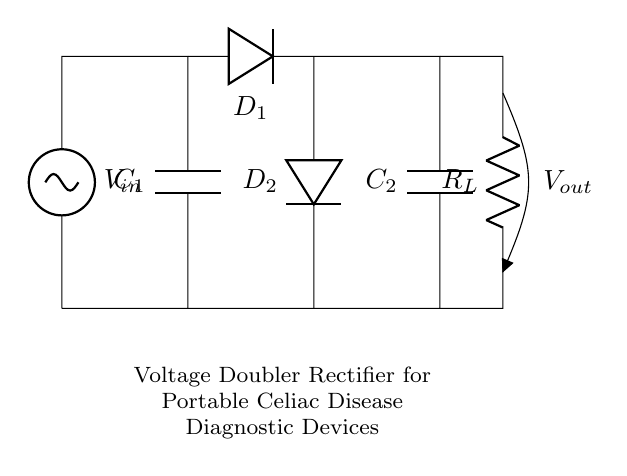What is the input voltage in this circuit? The input voltage is indicated by the label $V_{in}$ near the voltage source in the diagram.
Answer: V_in How many capacitors are present in the circuit? The circuit diagram shows two capacitors labeled $C_1$ and $C_2$.
Answer: 2 What type of rectifier is this circuit? The circuit is identified as a voltage doubler rectifier, as indicated in the title below the circuit.
Answer: Voltage doubler rectifier What is the purpose of the diodes in this circuit? The diodes, labeled $D_1$ and $D_2$, are used for rectification, allowing current to pass in one direction and charging the capacitors.
Answer: Rectification How does the output voltage relate to the input voltage? In a voltage doubler rectifier, the output voltage $V_{out}$ is approximately twice the input voltage $V_{in}$ due to the arrangement of components.
Answer: Approximately 2 V_in What is the role of the load resistor in this circuit? The load resistor, labeled $R_L$, simulates the load connected to the output and helps dissipate the energy stored in the capacitors.
Answer: Dissipate energy What happens if one of the diodes fails? If one of the diodes fails, the rectification process is disrupted, potentially leading to a significantly lower output voltage or no output at all.
Answer: Lower output voltage 